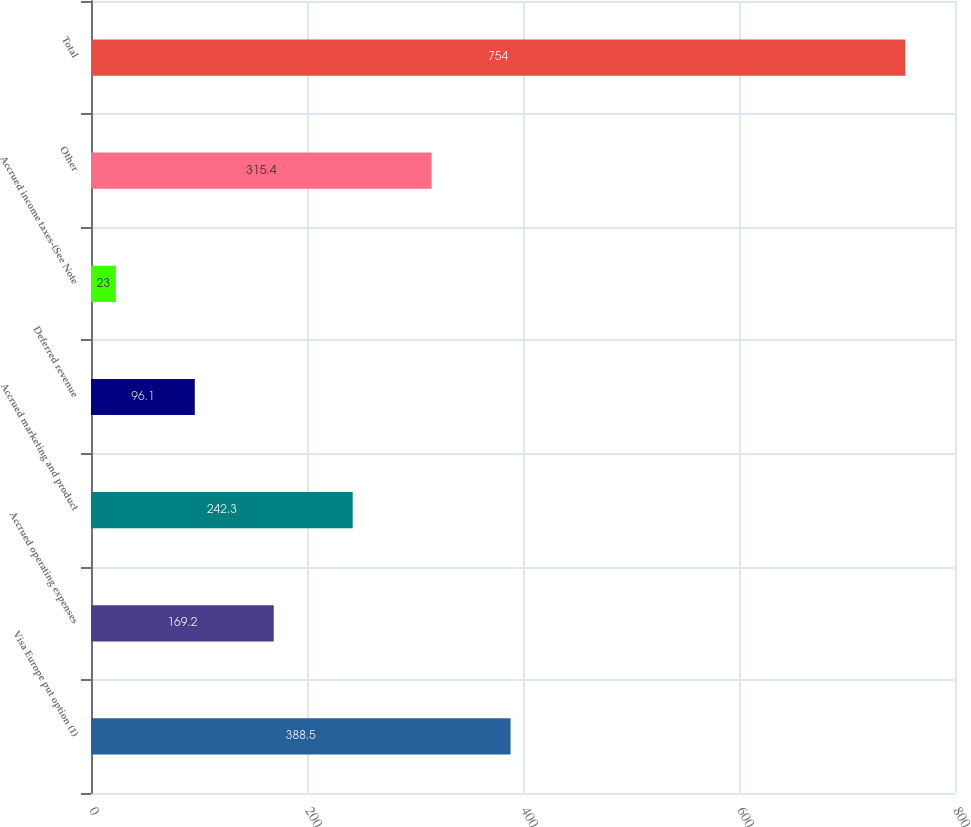Convert chart. <chart><loc_0><loc_0><loc_500><loc_500><bar_chart><fcel>Visa Europe put option (1)<fcel>Accrued operating expenses<fcel>Accrued marketing and product<fcel>Deferred revenue<fcel>Accrued income taxes-(See Note<fcel>Other<fcel>Total<nl><fcel>388.5<fcel>169.2<fcel>242.3<fcel>96.1<fcel>23<fcel>315.4<fcel>754<nl></chart> 